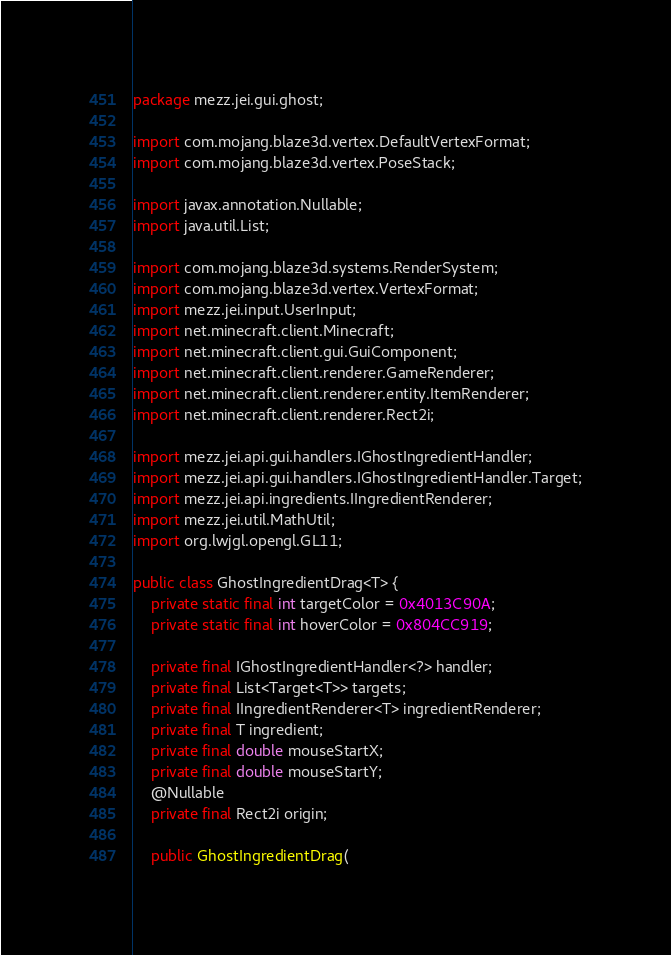Convert code to text. <code><loc_0><loc_0><loc_500><loc_500><_Java_>package mezz.jei.gui.ghost;

import com.mojang.blaze3d.vertex.DefaultVertexFormat;
import com.mojang.blaze3d.vertex.PoseStack;

import javax.annotation.Nullable;
import java.util.List;

import com.mojang.blaze3d.systems.RenderSystem;
import com.mojang.blaze3d.vertex.VertexFormat;
import mezz.jei.input.UserInput;
import net.minecraft.client.Minecraft;
import net.minecraft.client.gui.GuiComponent;
import net.minecraft.client.renderer.GameRenderer;
import net.minecraft.client.renderer.entity.ItemRenderer;
import net.minecraft.client.renderer.Rect2i;

import mezz.jei.api.gui.handlers.IGhostIngredientHandler;
import mezz.jei.api.gui.handlers.IGhostIngredientHandler.Target;
import mezz.jei.api.ingredients.IIngredientRenderer;
import mezz.jei.util.MathUtil;
import org.lwjgl.opengl.GL11;

public class GhostIngredientDrag<T> {
	private static final int targetColor = 0x4013C90A;
	private static final int hoverColor = 0x804CC919;

	private final IGhostIngredientHandler<?> handler;
	private final List<Target<T>> targets;
	private final IIngredientRenderer<T> ingredientRenderer;
	private final T ingredient;
	private final double mouseStartX;
	private final double mouseStartY;
	@Nullable
	private final Rect2i origin;

	public GhostIngredientDrag(</code> 